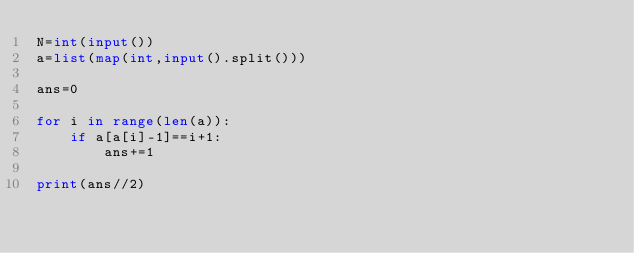<code> <loc_0><loc_0><loc_500><loc_500><_Python_>N=int(input())
a=list(map(int,input().split()))

ans=0

for i in range(len(a)):
    if a[a[i]-1]==i+1:
        ans+=1

print(ans//2)</code> 